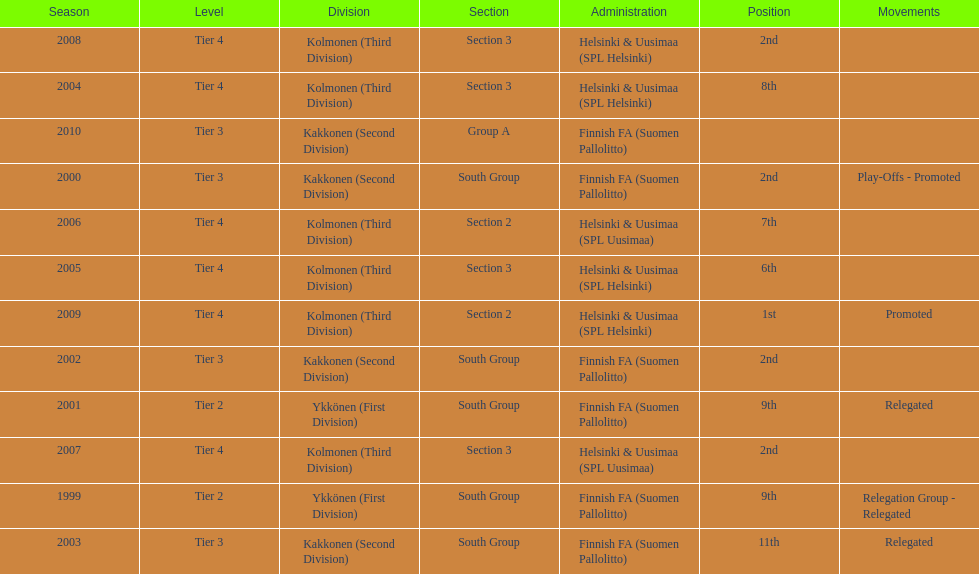How many tiers had more than one relegated movement? 1. 